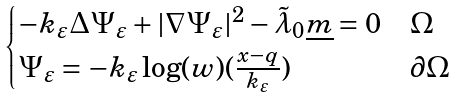Convert formula to latex. <formula><loc_0><loc_0><loc_500><loc_500>\begin{cases} - k _ { \varepsilon } \Delta \Psi _ { \varepsilon } + | \nabla \Psi _ { \varepsilon } | ^ { 2 } - \tilde { \lambda } _ { 0 } \underline { m } = 0 & \Omega \\ \Psi _ { \varepsilon } = - k _ { \varepsilon } \log ( w ) ( \frac { x - q } { k _ { \varepsilon } } ) & \partial \Omega \end{cases}</formula> 